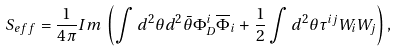Convert formula to latex. <formula><loc_0><loc_0><loc_500><loc_500>S _ { e f f } = { \frac { 1 } { 4 \pi } } I m \, \left ( \int d ^ { 2 } \theta d ^ { 2 } \bar { \theta } \Phi _ { D } ^ { i } \overline { \Phi } _ { i } + { \frac { 1 } { 2 } } \int d ^ { 2 } \theta \tau ^ { i j } W _ { i } W _ { j } \right ) ,</formula> 